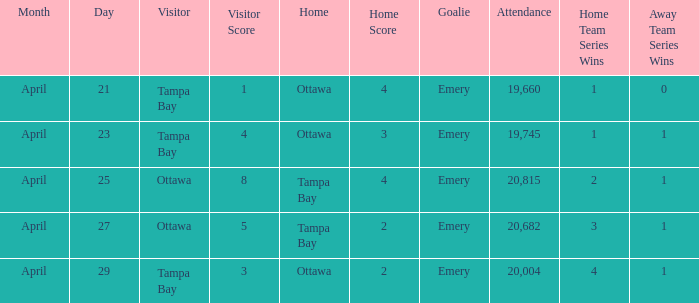What is the date of the game when attendance is more than 20,682? April 25. Parse the table in full. {'header': ['Month', 'Day', 'Visitor', 'Visitor Score', 'Home', 'Home Score', 'Goalie', 'Attendance', 'Home Team Series Wins', 'Away Team Series Wins'], 'rows': [['April', '21', 'Tampa Bay', '1', 'Ottawa', '4', 'Emery', '19,660', '1', '0'], ['April', '23', 'Tampa Bay', '4', 'Ottawa', '3', 'Emery', '19,745', '1', '1'], ['April', '25', 'Ottawa', '8', 'Tampa Bay', '4', 'Emery', '20,815', '2', '1'], ['April', '27', 'Ottawa', '5', 'Tampa Bay', '2', 'Emery', '20,682', '3', '1'], ['April', '29', 'Tampa Bay', '3', 'Ottawa', '2', 'Emery', '20,004', '4', '1']]} 